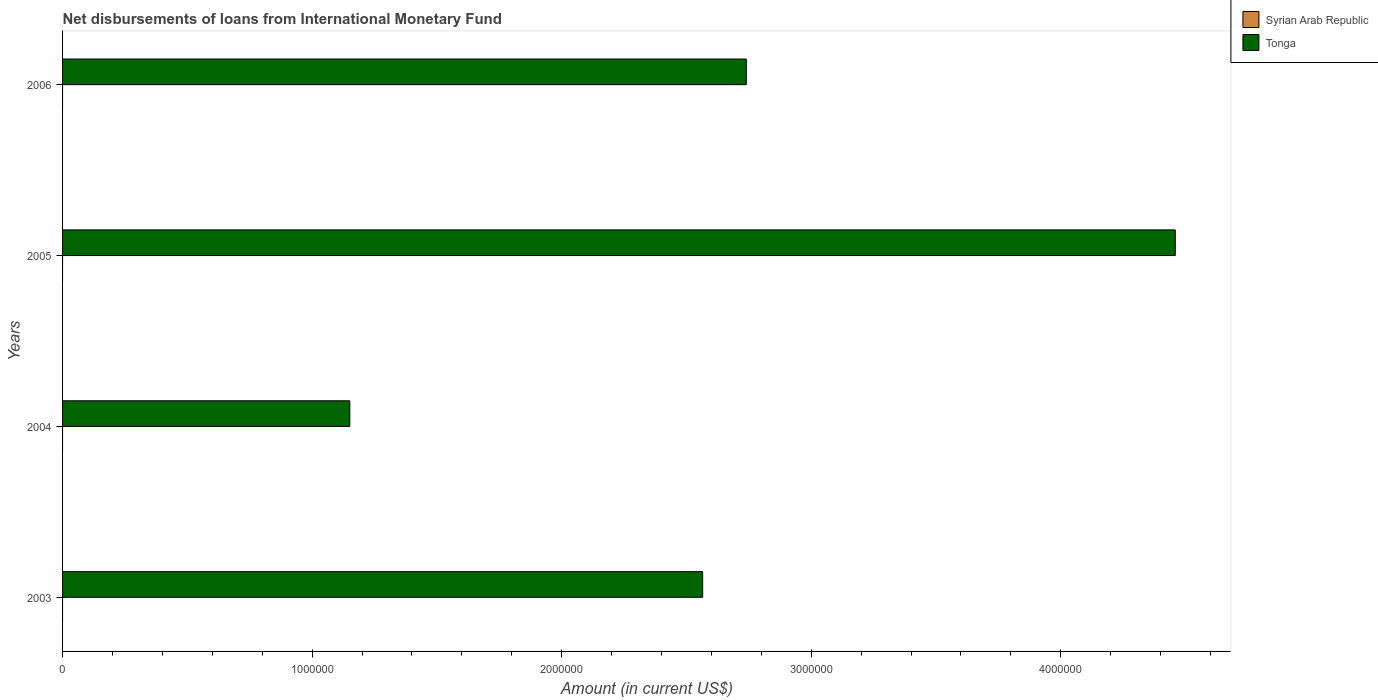How many different coloured bars are there?
Provide a short and direct response. 1. Are the number of bars per tick equal to the number of legend labels?
Your answer should be compact. No. What is the label of the 4th group of bars from the top?
Offer a very short reply. 2003. In how many cases, is the number of bars for a given year not equal to the number of legend labels?
Offer a terse response. 4. What is the amount of loans disbursed in Tonga in 2005?
Provide a succinct answer. 4.46e+06. Across all years, what is the maximum amount of loans disbursed in Tonga?
Ensure brevity in your answer.  4.46e+06. Across all years, what is the minimum amount of loans disbursed in Tonga?
Your answer should be very brief. 1.15e+06. What is the difference between the amount of loans disbursed in Tonga in 2004 and that in 2005?
Give a very brief answer. -3.31e+06. What is the difference between the amount of loans disbursed in Syrian Arab Republic in 2004 and the amount of loans disbursed in Tonga in 2006?
Your response must be concise. -2.74e+06. What is the ratio of the amount of loans disbursed in Tonga in 2003 to that in 2004?
Your answer should be compact. 2.23. What is the difference between the highest and the second highest amount of loans disbursed in Tonga?
Provide a short and direct response. 1.72e+06. What is the difference between the highest and the lowest amount of loans disbursed in Tonga?
Your answer should be compact. 3.31e+06. How many bars are there?
Keep it short and to the point. 4. Are the values on the major ticks of X-axis written in scientific E-notation?
Your response must be concise. No. Does the graph contain any zero values?
Provide a succinct answer. Yes. How many legend labels are there?
Ensure brevity in your answer.  2. What is the title of the graph?
Give a very brief answer. Net disbursements of loans from International Monetary Fund. Does "North America" appear as one of the legend labels in the graph?
Your response must be concise. No. What is the Amount (in current US$) of Tonga in 2003?
Give a very brief answer. 2.56e+06. What is the Amount (in current US$) in Syrian Arab Republic in 2004?
Your answer should be compact. 0. What is the Amount (in current US$) of Tonga in 2004?
Offer a terse response. 1.15e+06. What is the Amount (in current US$) in Syrian Arab Republic in 2005?
Provide a short and direct response. 0. What is the Amount (in current US$) in Tonga in 2005?
Give a very brief answer. 4.46e+06. What is the Amount (in current US$) in Syrian Arab Republic in 2006?
Give a very brief answer. 0. What is the Amount (in current US$) in Tonga in 2006?
Make the answer very short. 2.74e+06. Across all years, what is the maximum Amount (in current US$) of Tonga?
Keep it short and to the point. 4.46e+06. Across all years, what is the minimum Amount (in current US$) in Tonga?
Provide a short and direct response. 1.15e+06. What is the total Amount (in current US$) in Tonga in the graph?
Provide a succinct answer. 1.09e+07. What is the difference between the Amount (in current US$) in Tonga in 2003 and that in 2004?
Provide a succinct answer. 1.41e+06. What is the difference between the Amount (in current US$) in Tonga in 2003 and that in 2005?
Keep it short and to the point. -1.89e+06. What is the difference between the Amount (in current US$) in Tonga in 2003 and that in 2006?
Your answer should be very brief. -1.75e+05. What is the difference between the Amount (in current US$) in Tonga in 2004 and that in 2005?
Keep it short and to the point. -3.31e+06. What is the difference between the Amount (in current US$) of Tonga in 2004 and that in 2006?
Your response must be concise. -1.59e+06. What is the difference between the Amount (in current US$) of Tonga in 2005 and that in 2006?
Provide a short and direct response. 1.72e+06. What is the average Amount (in current US$) of Tonga per year?
Your answer should be very brief. 2.73e+06. What is the ratio of the Amount (in current US$) of Tonga in 2003 to that in 2004?
Provide a short and direct response. 2.23. What is the ratio of the Amount (in current US$) of Tonga in 2003 to that in 2005?
Provide a short and direct response. 0.58. What is the ratio of the Amount (in current US$) in Tonga in 2003 to that in 2006?
Keep it short and to the point. 0.94. What is the ratio of the Amount (in current US$) in Tonga in 2004 to that in 2005?
Provide a short and direct response. 0.26. What is the ratio of the Amount (in current US$) in Tonga in 2004 to that in 2006?
Offer a very short reply. 0.42. What is the ratio of the Amount (in current US$) of Tonga in 2005 to that in 2006?
Your response must be concise. 1.63. What is the difference between the highest and the second highest Amount (in current US$) in Tonga?
Provide a succinct answer. 1.72e+06. What is the difference between the highest and the lowest Amount (in current US$) of Tonga?
Keep it short and to the point. 3.31e+06. 